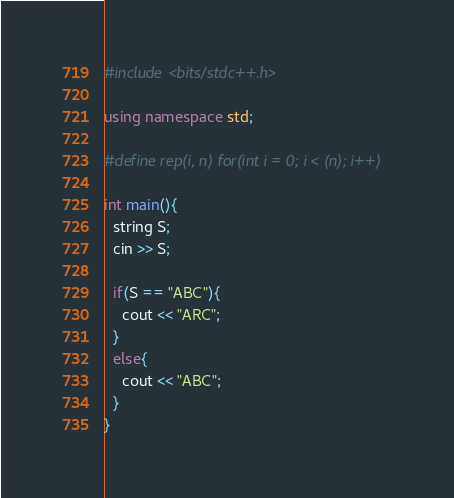<code> <loc_0><loc_0><loc_500><loc_500><_C++_>#include <bits/stdc++.h>

using namespace std;

#define rep(i, n) for(int i = 0; i < (n); i++)

int main(){
  string S;
  cin >> S;

  if(S == "ABC"){
    cout << "ARC";
  }
  else{
    cout << "ABC";
  }
}
</code> 